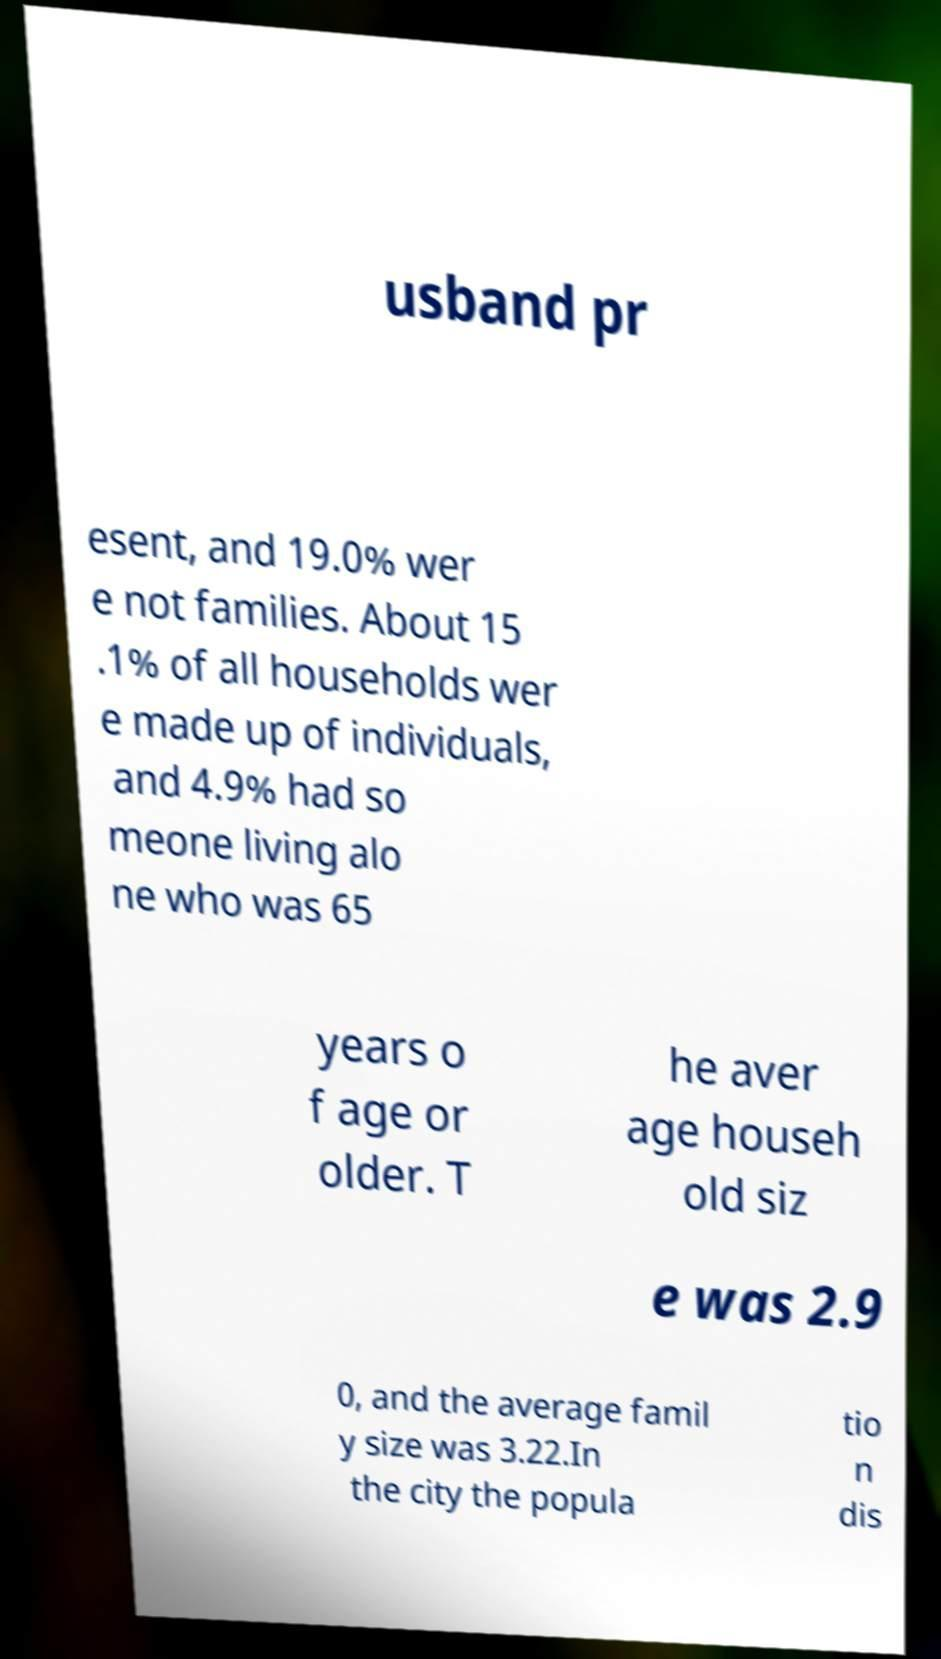Please identify and transcribe the text found in this image. usband pr esent, and 19.0% wer e not families. About 15 .1% of all households wer e made up of individuals, and 4.9% had so meone living alo ne who was 65 years o f age or older. T he aver age househ old siz e was 2.9 0, and the average famil y size was 3.22.In the city the popula tio n dis 